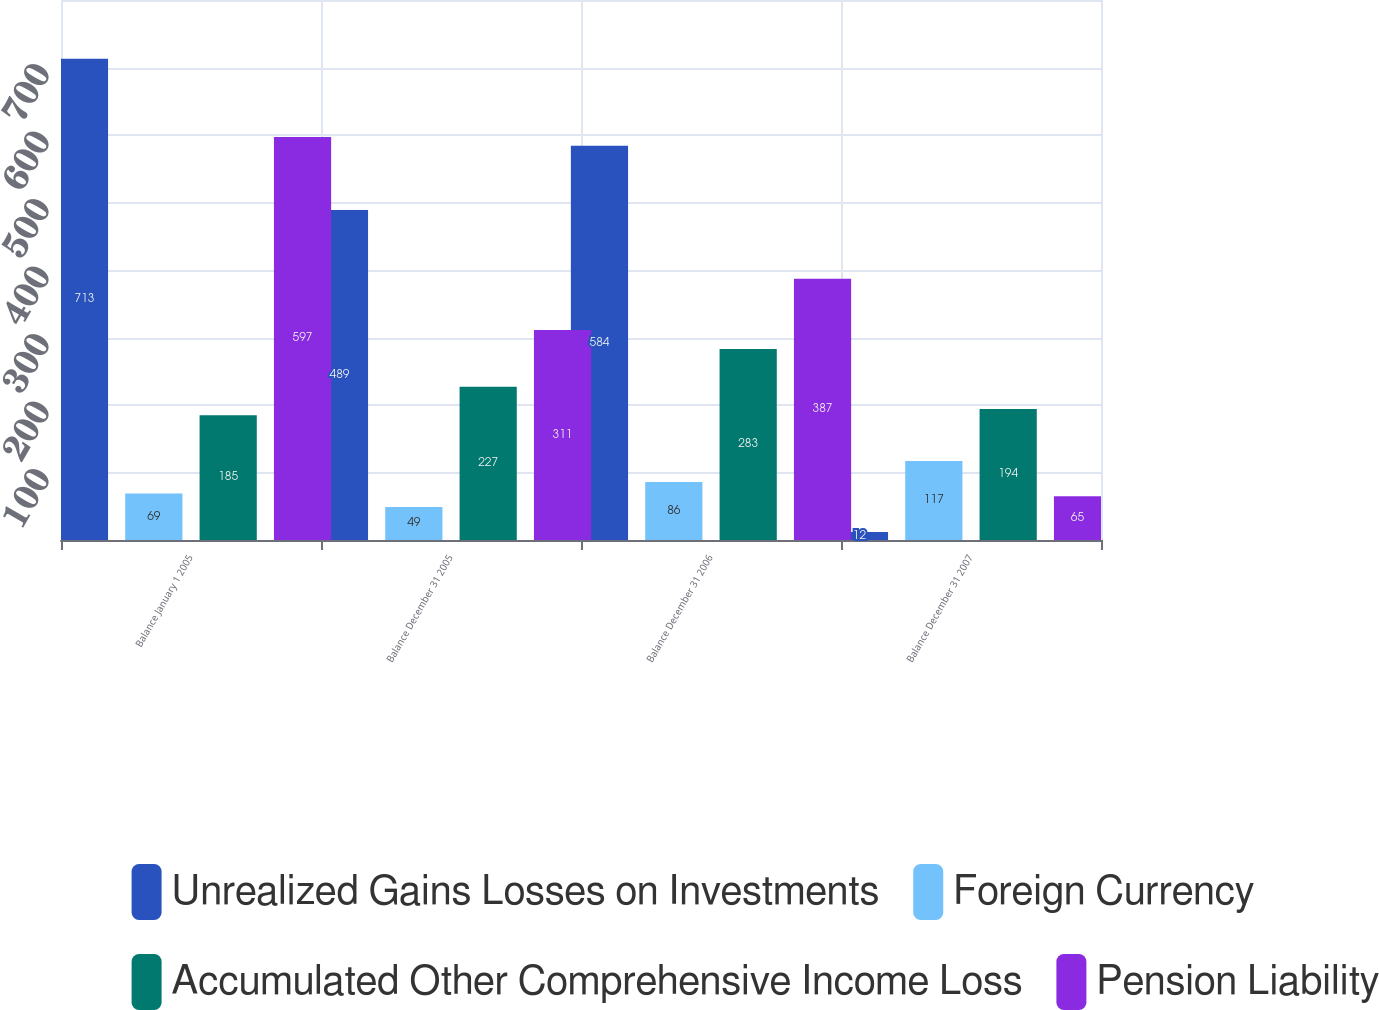Convert chart. <chart><loc_0><loc_0><loc_500><loc_500><stacked_bar_chart><ecel><fcel>Balance January 1 2005<fcel>Balance December 31 2005<fcel>Balance December 31 2006<fcel>Balance December 31 2007<nl><fcel>Unrealized Gains Losses on Investments<fcel>713<fcel>489<fcel>584<fcel>12<nl><fcel>Foreign Currency<fcel>69<fcel>49<fcel>86<fcel>117<nl><fcel>Accumulated Other Comprehensive Income Loss<fcel>185<fcel>227<fcel>283<fcel>194<nl><fcel>Pension Liability<fcel>597<fcel>311<fcel>387<fcel>65<nl></chart> 